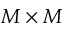Convert formula to latex. <formula><loc_0><loc_0><loc_500><loc_500>M \times M</formula> 